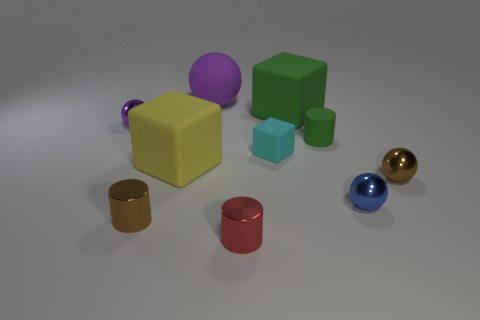What number of other things are there of the same shape as the small blue thing?
Provide a succinct answer. 3. There is another small matte thing that is the same shape as the red thing; what is its color?
Offer a very short reply. Green. Is there anything else that has the same color as the tiny block?
Your answer should be compact. No. Are there more cyan blocks than large blue rubber cylinders?
Make the answer very short. Yes. Does the small blue sphere have the same material as the yellow thing?
Provide a succinct answer. No. How many brown cylinders are made of the same material as the small red cylinder?
Offer a very short reply. 1. There is a green rubber cube; is its size the same as the metal thing behind the brown metal ball?
Provide a succinct answer. No. What color is the sphere that is both right of the purple metallic ball and on the left side of the green cylinder?
Give a very brief answer. Purple. Are there any tiny brown shiny things that are on the right side of the tiny cylinder that is to the left of the yellow block?
Give a very brief answer. Yes. Are there an equal number of tiny shiny things that are to the left of the large purple sphere and big matte blocks?
Provide a succinct answer. Yes. 